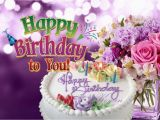Write a detailed description of this image, do not forget about the texts on it if they exist. Also, do not forget to mention the type / style of the image. No bullet points. The image presents a vibrant birthday celebration theme, featuring a centerpiece of a white-frosted round birthday cake adorned with multiple lit candles of varied colors, and elegantly decorated with the cursive inscription 'Happy Birthday' in pastel tones. Adjacent to the cake is an arrangement of fresh flowers, including blossoms of white, pink, and varied shades of purple, meticulously assembled. The flowers add a touch of natural elegance to the scene. The backdrop consists of a layered purple gradient, adding visual depth to the composition. Superimposed over this festive display is the phrase 'Happy Birthday to You', rendered in a whimsical, colorful font that appears to pop out from the surface. The artistic approach of the image is digital graphic design, characterized by bold colors, clean lines, and a clear, legible typographic choice. This style amplifies the exuberant atmosphere typically associated with birthday celebrations. 